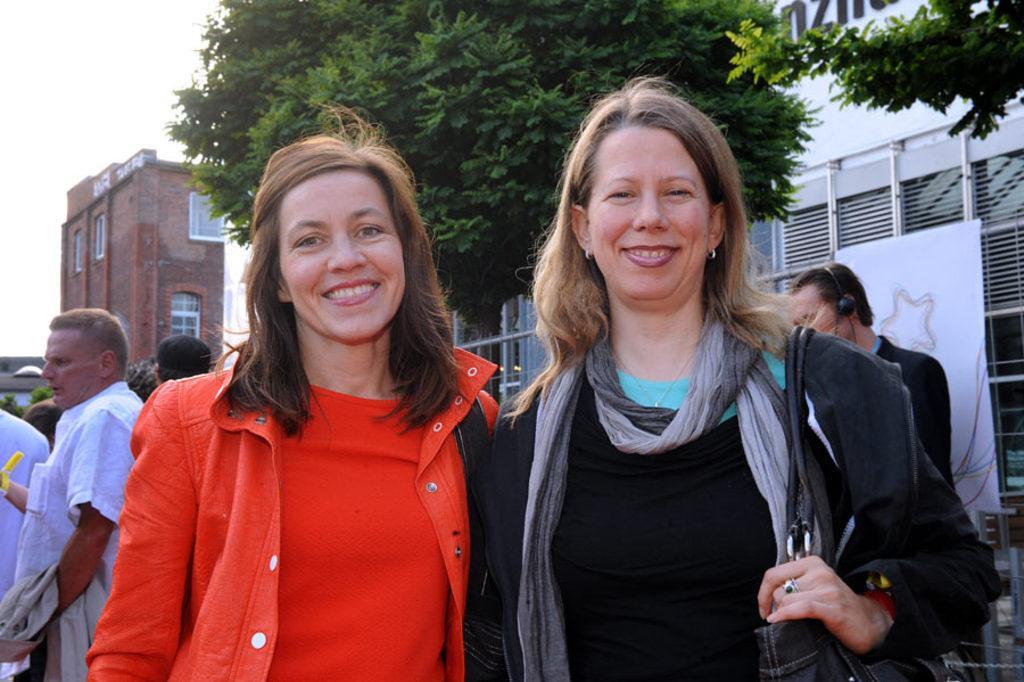Please provide a concise description of this image. There are two ladies standing and smiling. Lady on the right is wearing a scarf and holding a bag. In the back there are many people. Also there is a tree. There are buildings with windows. In the background there is sky. 